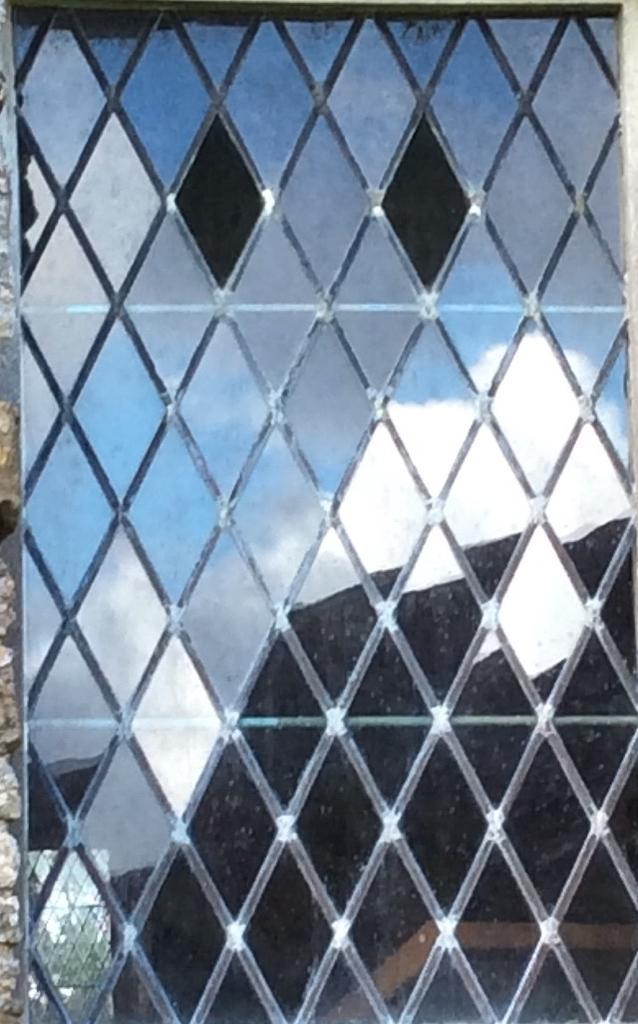Could you give a brief overview of what you see in this image? In this picture there is a glass window and there is a reflection of a house, tree and sky and clouds on the mirror. On the left side of the image there is a wall. 